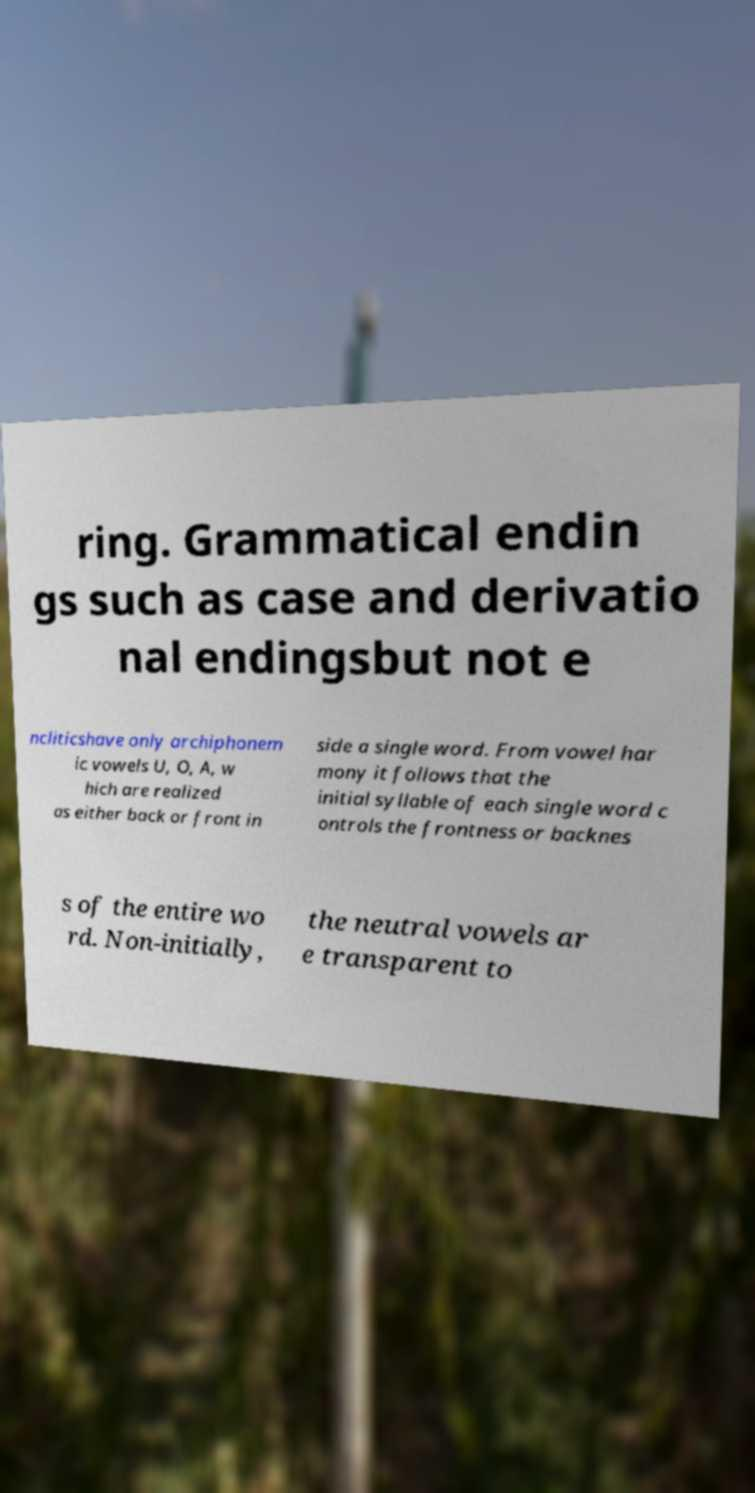Could you assist in decoding the text presented in this image and type it out clearly? ring. Grammatical endin gs such as case and derivatio nal endingsbut not e ncliticshave only archiphonem ic vowels U, O, A, w hich are realized as either back or front in side a single word. From vowel har mony it follows that the initial syllable of each single word c ontrols the frontness or backnes s of the entire wo rd. Non-initially, the neutral vowels ar e transparent to 